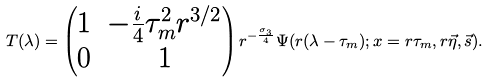<formula> <loc_0><loc_0><loc_500><loc_500>T ( \lambda ) = \begin{pmatrix} 1 & - \frac { i } { 4 } \tau _ { m } ^ { 2 } r ^ { 3 / 2 } \\ 0 & 1 \end{pmatrix} r ^ { - \frac { \sigma _ { 3 } } { 4 } } \Psi ( r ( \lambda - \tau _ { m } ) ; x = r \tau _ { m } , r \vec { \eta } , \vec { s } ) .</formula> 